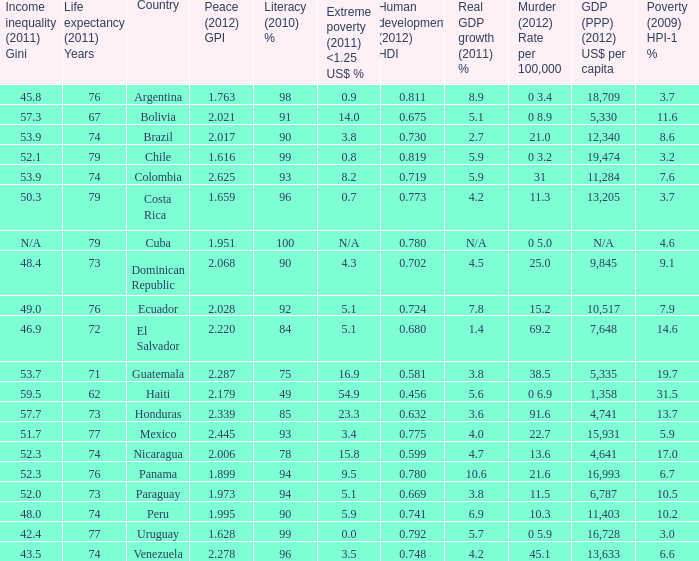What is the total poverty (2009) HPI-1 % when the extreme poverty (2011) <1.25 US$ % of 16.9, and the human development (2012) HDI is less than 0.581? None. 